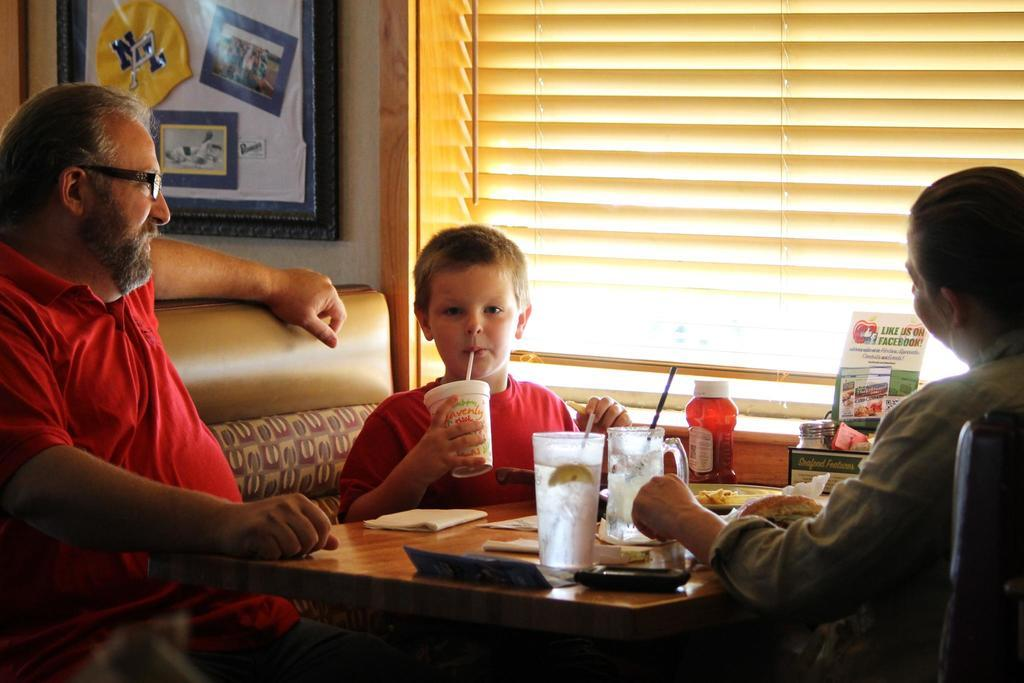How many people are in the image? There are three people in the image: a man, a woman, and a boy. What are they doing in the image? They are sitting at a table in a restaurant. What is the boy doing with the cup? The boy is sipping from a cup using a straw. Where is the table located in relation to the window? The table is beside a window. What can be seen in the background of the image? There is a photo frame in the background. What type of key is the boy using to unlock the dolls in the image? There are no keys or dolls present in the image. 